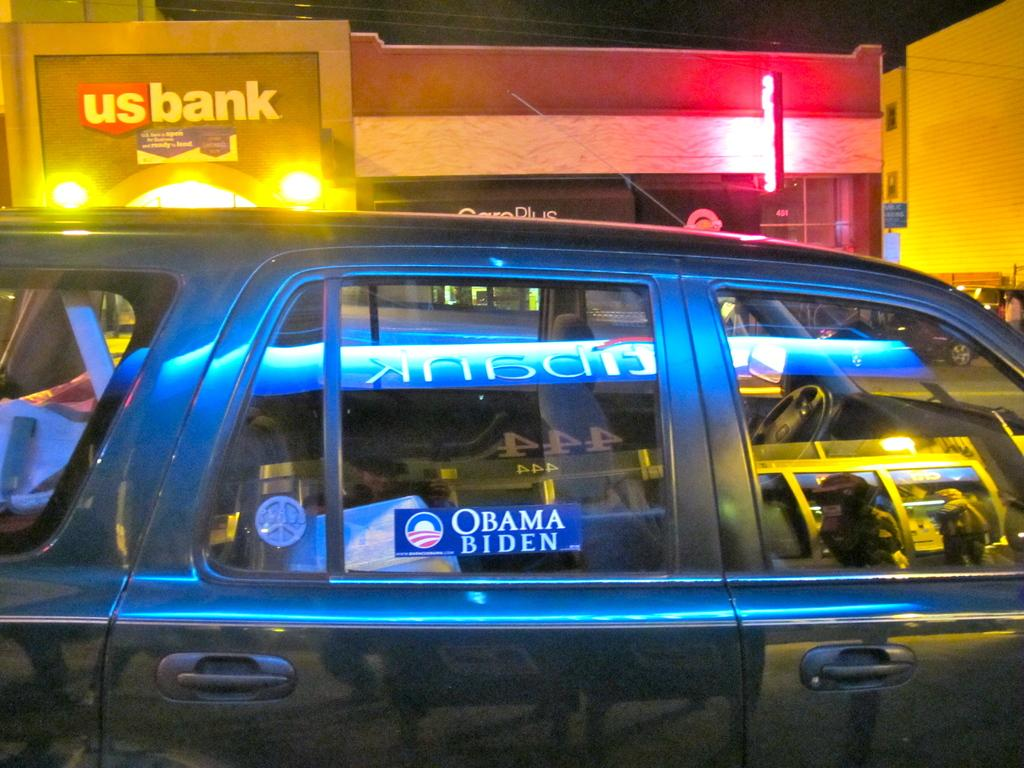<image>
Share a concise interpretation of the image provided. a suv with a obama biden sticker on the window 